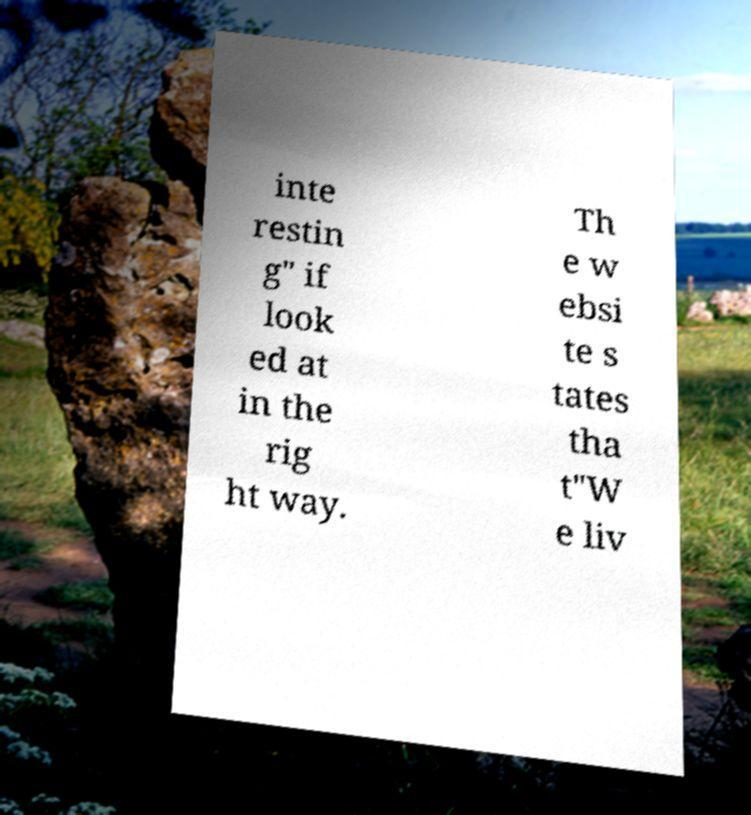For documentation purposes, I need the text within this image transcribed. Could you provide that? inte restin g" if look ed at in the rig ht way. Th e w ebsi te s tates tha t"W e liv 